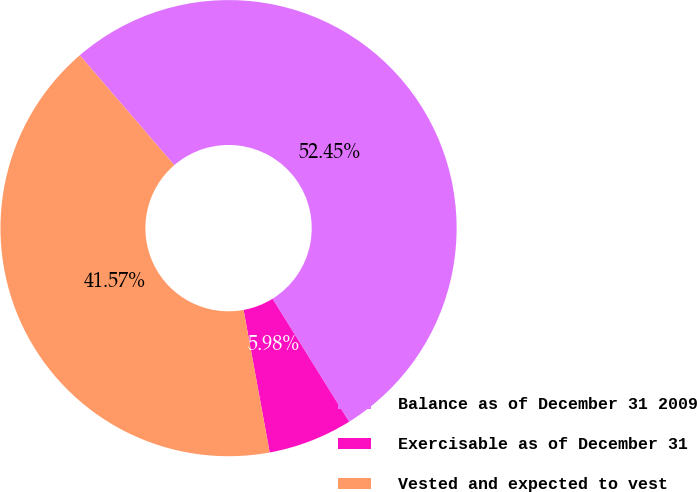Convert chart. <chart><loc_0><loc_0><loc_500><loc_500><pie_chart><fcel>Balance as of December 31 2009<fcel>Exercisable as of December 31<fcel>Vested and expected to vest<nl><fcel>52.44%<fcel>5.98%<fcel>41.57%<nl></chart> 